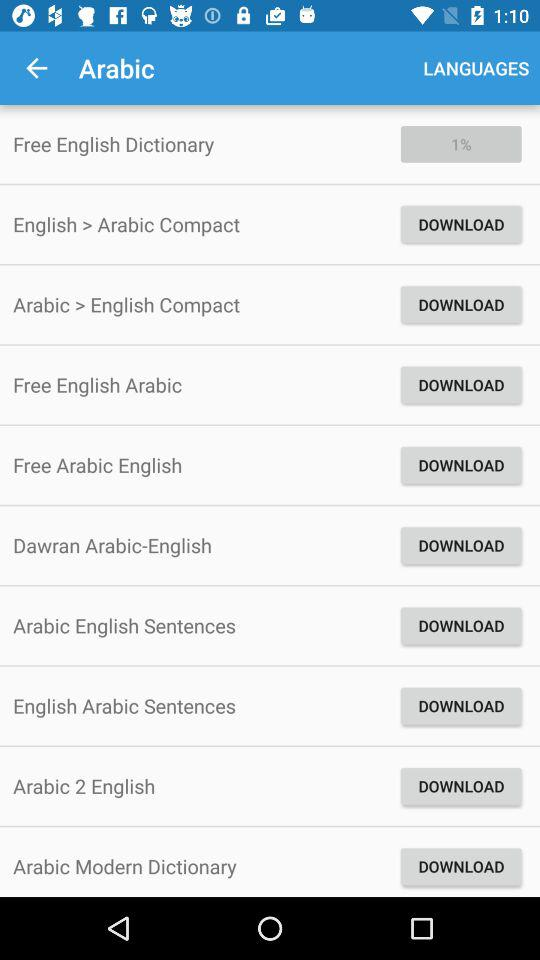What percentage of "Free English Dictionary" has been downloaded? The percentage of "Free English Dictionary" that has been downloaded is 1. 